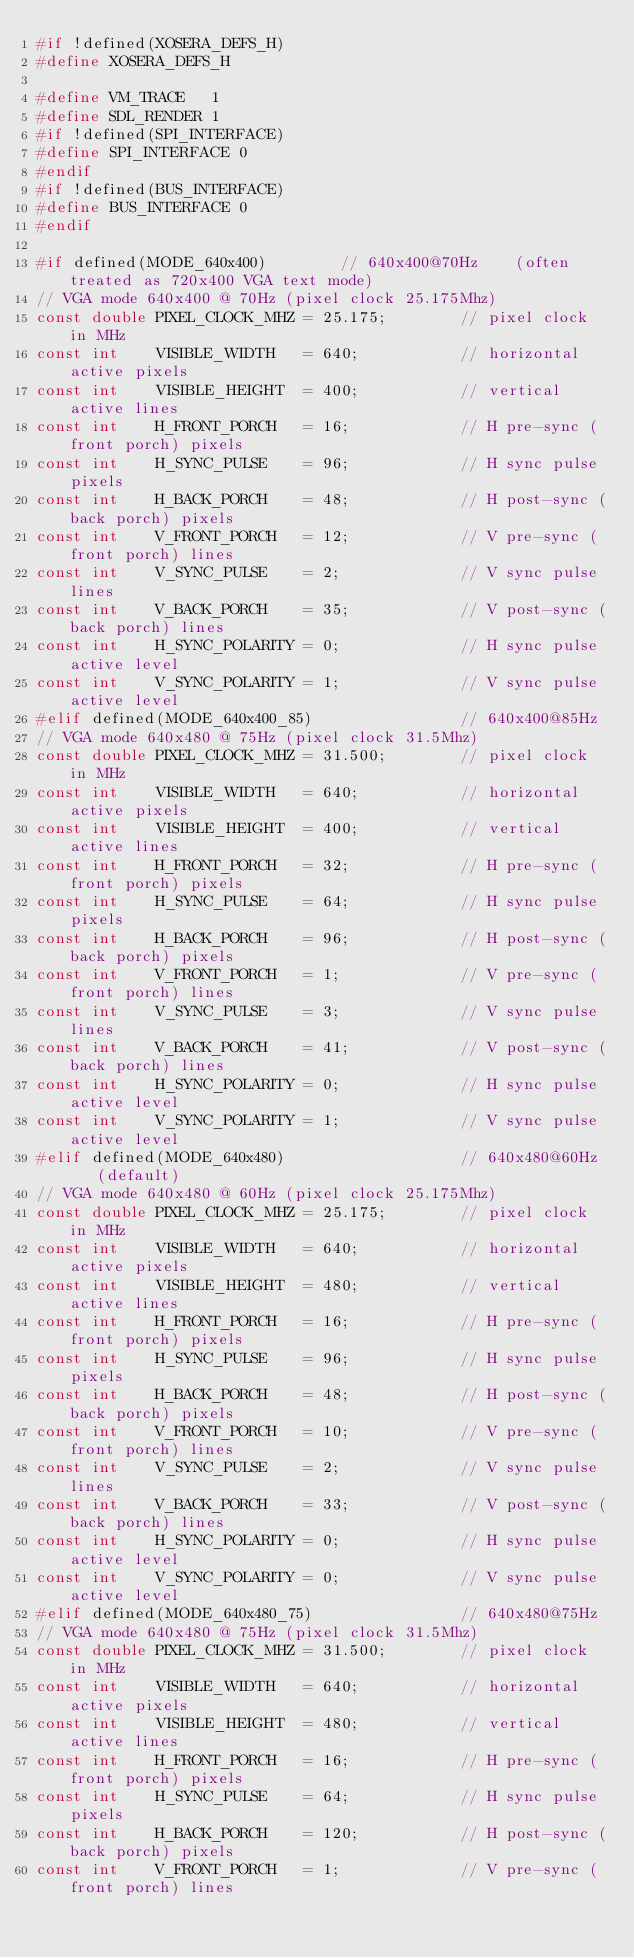Convert code to text. <code><loc_0><loc_0><loc_500><loc_500><_C_>#if !defined(XOSERA_DEFS_H)
#define XOSERA_DEFS_H

#define VM_TRACE   1
#define SDL_RENDER 1
#if !defined(SPI_INTERFACE)
#define SPI_INTERFACE 0
#endif
#if !defined(BUS_INTERFACE)
#define BUS_INTERFACE 0
#endif

#if defined(MODE_640x400)        //	640x400@70Hz 	(often treated as 720x400 VGA text mode)
// VGA mode 640x400 @ 70Hz (pixel clock 25.175Mhz)
const double PIXEL_CLOCK_MHZ = 25.175;        // pixel clock in MHz
const int    VISIBLE_WIDTH   = 640;           // horizontal active pixels
const int    VISIBLE_HEIGHT  = 400;           // vertical active lines
const int    H_FRONT_PORCH   = 16;            // H pre-sync (front porch) pixels
const int    H_SYNC_PULSE    = 96;            // H sync pulse pixels
const int    H_BACK_PORCH    = 48;            // H post-sync (back porch) pixels
const int    V_FRONT_PORCH   = 12;            // V pre-sync (front porch) lines
const int    V_SYNC_PULSE    = 2;             // V sync pulse lines
const int    V_BACK_PORCH    = 35;            // V post-sync (back porch) lines
const int    H_SYNC_POLARITY = 0;             // H sync pulse active level
const int    V_SYNC_POLARITY = 1;             // V sync pulse active level
#elif defined(MODE_640x400_85)                // 640x400@85Hz
// VGA mode 640x480 @ 75Hz (pixel clock 31.5Mhz)
const double PIXEL_CLOCK_MHZ = 31.500;        // pixel clock in MHz
const int    VISIBLE_WIDTH   = 640;           // horizontal active pixels
const int    VISIBLE_HEIGHT  = 400;           // vertical active lines
const int    H_FRONT_PORCH   = 32;            // H pre-sync (front porch) pixels
const int    H_SYNC_PULSE    = 64;            // H sync pulse pixels
const int    H_BACK_PORCH    = 96;            // H post-sync (back porch) pixels
const int    V_FRONT_PORCH   = 1;             // V pre-sync (front porch) lines
const int    V_SYNC_PULSE    = 3;             // V sync pulse lines
const int    V_BACK_PORCH    = 41;            // V post-sync (back porch) lines
const int    H_SYNC_POLARITY = 0;             // H sync pulse active level
const int    V_SYNC_POLARITY = 1;             // V sync pulse active level
#elif defined(MODE_640x480)                   // 640x480@60Hz	(default)
// VGA mode 640x480 @ 60Hz (pixel clock 25.175Mhz)
const double PIXEL_CLOCK_MHZ = 25.175;        // pixel clock in MHz
const int    VISIBLE_WIDTH   = 640;           // horizontal active pixels
const int    VISIBLE_HEIGHT  = 480;           // vertical active lines
const int    H_FRONT_PORCH   = 16;            // H pre-sync (front porch) pixels
const int    H_SYNC_PULSE    = 96;            // H sync pulse pixels
const int    H_BACK_PORCH    = 48;            // H post-sync (back porch) pixels
const int    V_FRONT_PORCH   = 10;            // V pre-sync (front porch) lines
const int    V_SYNC_PULSE    = 2;             // V sync pulse lines
const int    V_BACK_PORCH    = 33;            // V post-sync (back porch) lines
const int    H_SYNC_POLARITY = 0;             // H sync pulse active level
const int    V_SYNC_POLARITY = 0;             // V sync pulse active level
#elif defined(MODE_640x480_75)                // 640x480@75Hz
// VGA mode 640x480 @ 75Hz (pixel clock 31.5Mhz)
const double PIXEL_CLOCK_MHZ = 31.500;        // pixel clock in MHz
const int    VISIBLE_WIDTH   = 640;           // horizontal active pixels
const int    VISIBLE_HEIGHT  = 480;           // vertical active lines
const int    H_FRONT_PORCH   = 16;            // H pre-sync (front porch) pixels
const int    H_SYNC_PULSE    = 64;            // H sync pulse pixels
const int    H_BACK_PORCH    = 120;           // H post-sync (back porch) pixels
const int    V_FRONT_PORCH   = 1;             // V pre-sync (front porch) lines</code> 